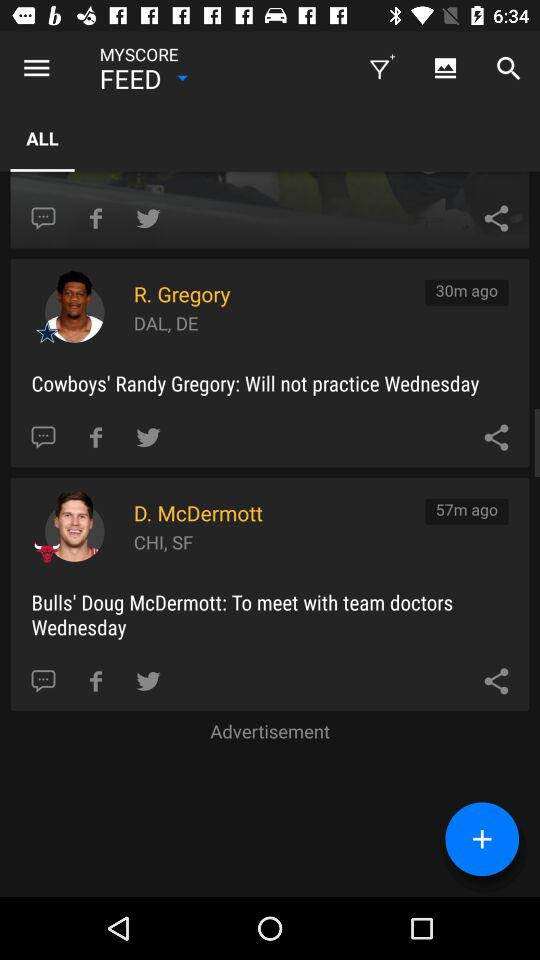Can you tell me what the sports updates are regarding for each player? Certainly! R. Gregory's update states he will not practice Wednesday, likely due to team decisions or health. D. McDermott's update indicates he is set to meet with team doctors Wednesday, suggesting a medical consultation. Is there any indication why McDermott needs to meet the team doctors? The update does not specify the exact reason why Doug McDermott is scheduled to meet with team doctors. It could be for a routine check-up or possibly related to an injury concern, but without more information, we can only speculate. 